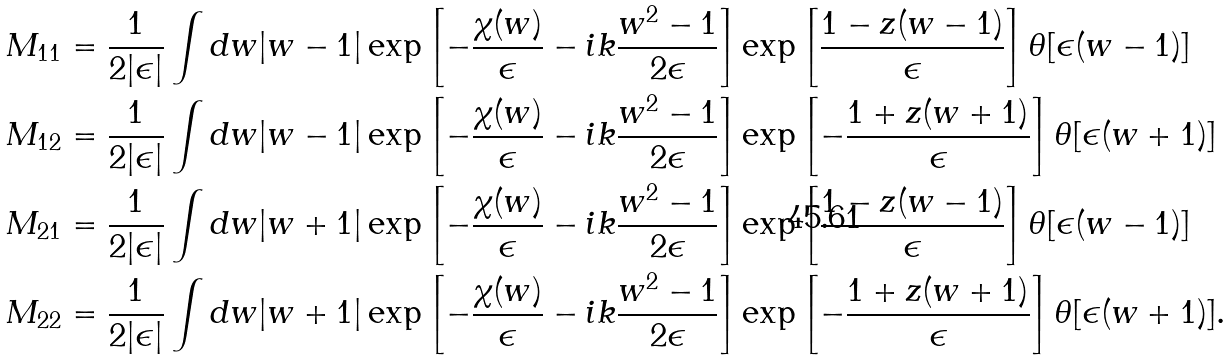<formula> <loc_0><loc_0><loc_500><loc_500>M _ { 1 1 } & = \frac { 1 } { 2 | \epsilon | } \int d w | w - 1 | \exp \left [ - \frac { \chi ( w ) } { \epsilon } - i k \frac { w ^ { 2 } - 1 } { 2 \epsilon } \right ] \exp \left [ \frac { 1 - z ( w - 1 ) } { \epsilon } \right ] \theta [ \epsilon ( w - 1 ) ] \\ M _ { 1 2 } & = \frac { 1 } { 2 | \epsilon | } \int d w | w - 1 | \exp \left [ - \frac { \chi ( w ) } { \epsilon } - i k \frac { w ^ { 2 } - 1 } { 2 \epsilon } \right ] \exp \left [ - \frac { 1 + z ( w + 1 ) } { \epsilon } \right ] \theta [ \epsilon ( w + 1 ) ] \\ M _ { 2 1 } & = \frac { 1 } { 2 | \epsilon | } \int d w | w + 1 | \exp \left [ - \frac { \chi ( w ) } { \epsilon } - i k \frac { w ^ { 2 } - 1 } { 2 \epsilon } \right ] \exp \left [ \frac { 1 - z ( w - 1 ) } { \epsilon } \right ] \theta [ \epsilon ( w - 1 ) ] \\ M _ { 2 2 } & = \frac { 1 } { 2 | \epsilon | } \int d w | w + 1 | \exp \left [ - \frac { \chi ( w ) } { \epsilon } - i k \frac { w ^ { 2 } - 1 } { 2 \epsilon } \right ] \exp \left [ - \frac { 1 + z ( w + 1 ) } { \epsilon } \right ] \theta [ \epsilon ( w + 1 ) ] .</formula> 